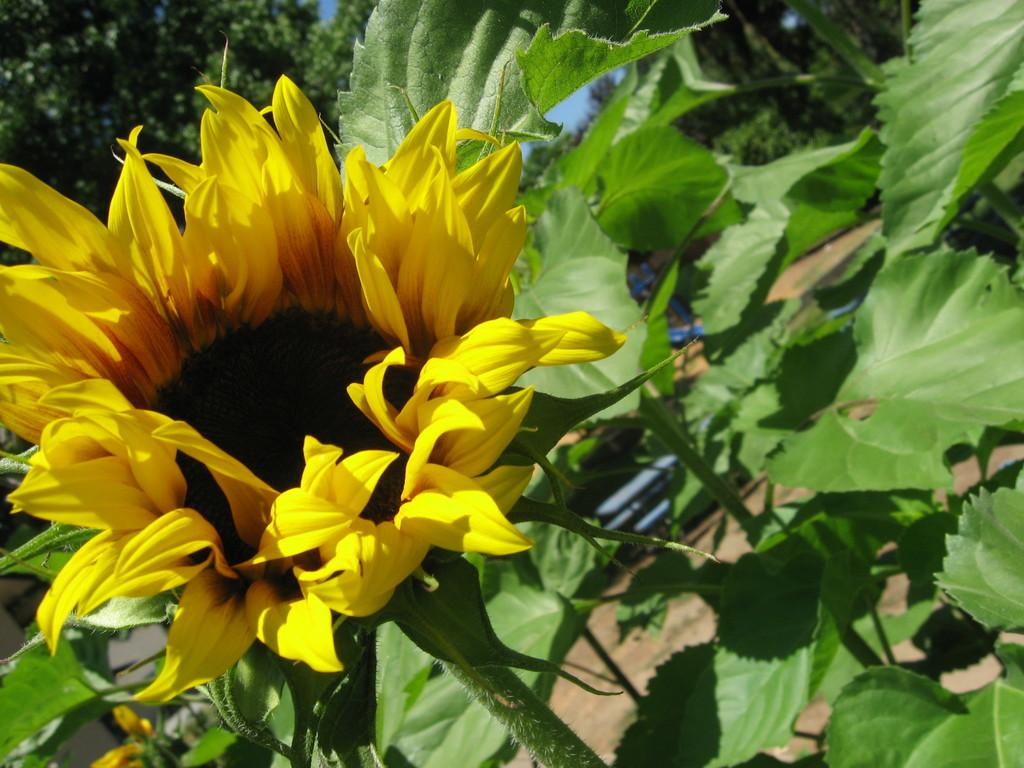What type of plant is featured in the image? There is a sunflower in the image. Where is the sunflower located on the plant? The sunflower is on a plant. What can be seen in the background of the image? There are trees and the sky visible in the background of the image. What type of vegetation is on the right side of the image? There are leaves on the right side of the image. How many brothers does the sunflower have in the image? The sunflower does not have any brothers in the image, as it is a plant and not a person. 